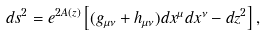<formula> <loc_0><loc_0><loc_500><loc_500>d s ^ { 2 } = e ^ { 2 A ( z ) } \left [ ( g _ { \mu \nu } + h _ { \mu \nu } ) d x ^ { \mu } d x ^ { \nu } - d z ^ { 2 } \right ] ,</formula> 